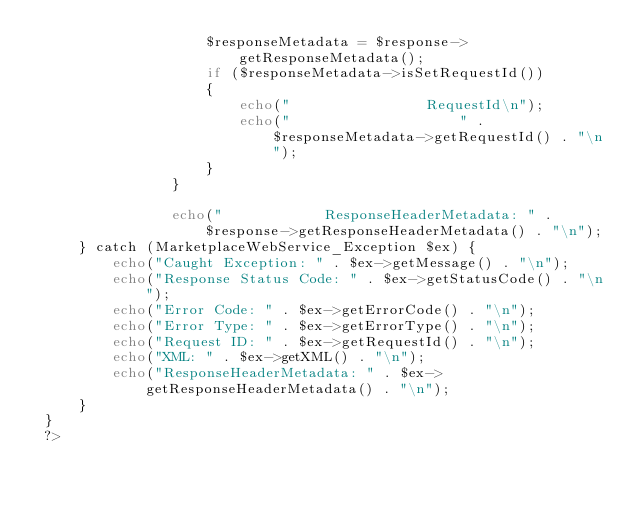Convert code to text. <code><loc_0><loc_0><loc_500><loc_500><_PHP_>                    $responseMetadata = $response->getResponseMetadata();
                    if ($responseMetadata->isSetRequestId()) 
                    {
                        echo("                RequestId\n");
                        echo("                    " . $responseMetadata->getRequestId() . "\n");
                    }
                } 

                echo("            ResponseHeaderMetadata: " . $response->getResponseHeaderMetadata() . "\n");
     } catch (MarketplaceWebService_Exception $ex) {
         echo("Caught Exception: " . $ex->getMessage() . "\n");
         echo("Response Status Code: " . $ex->getStatusCode() . "\n");
         echo("Error Code: " . $ex->getErrorCode() . "\n");
         echo("Error Type: " . $ex->getErrorType() . "\n");
         echo("Request ID: " . $ex->getRequestId() . "\n");
         echo("XML: " . $ex->getXML() . "\n");
         echo("ResponseHeaderMetadata: " . $ex->getResponseHeaderMetadata() . "\n");
     }
 }
 ?>
                                            
</code> 